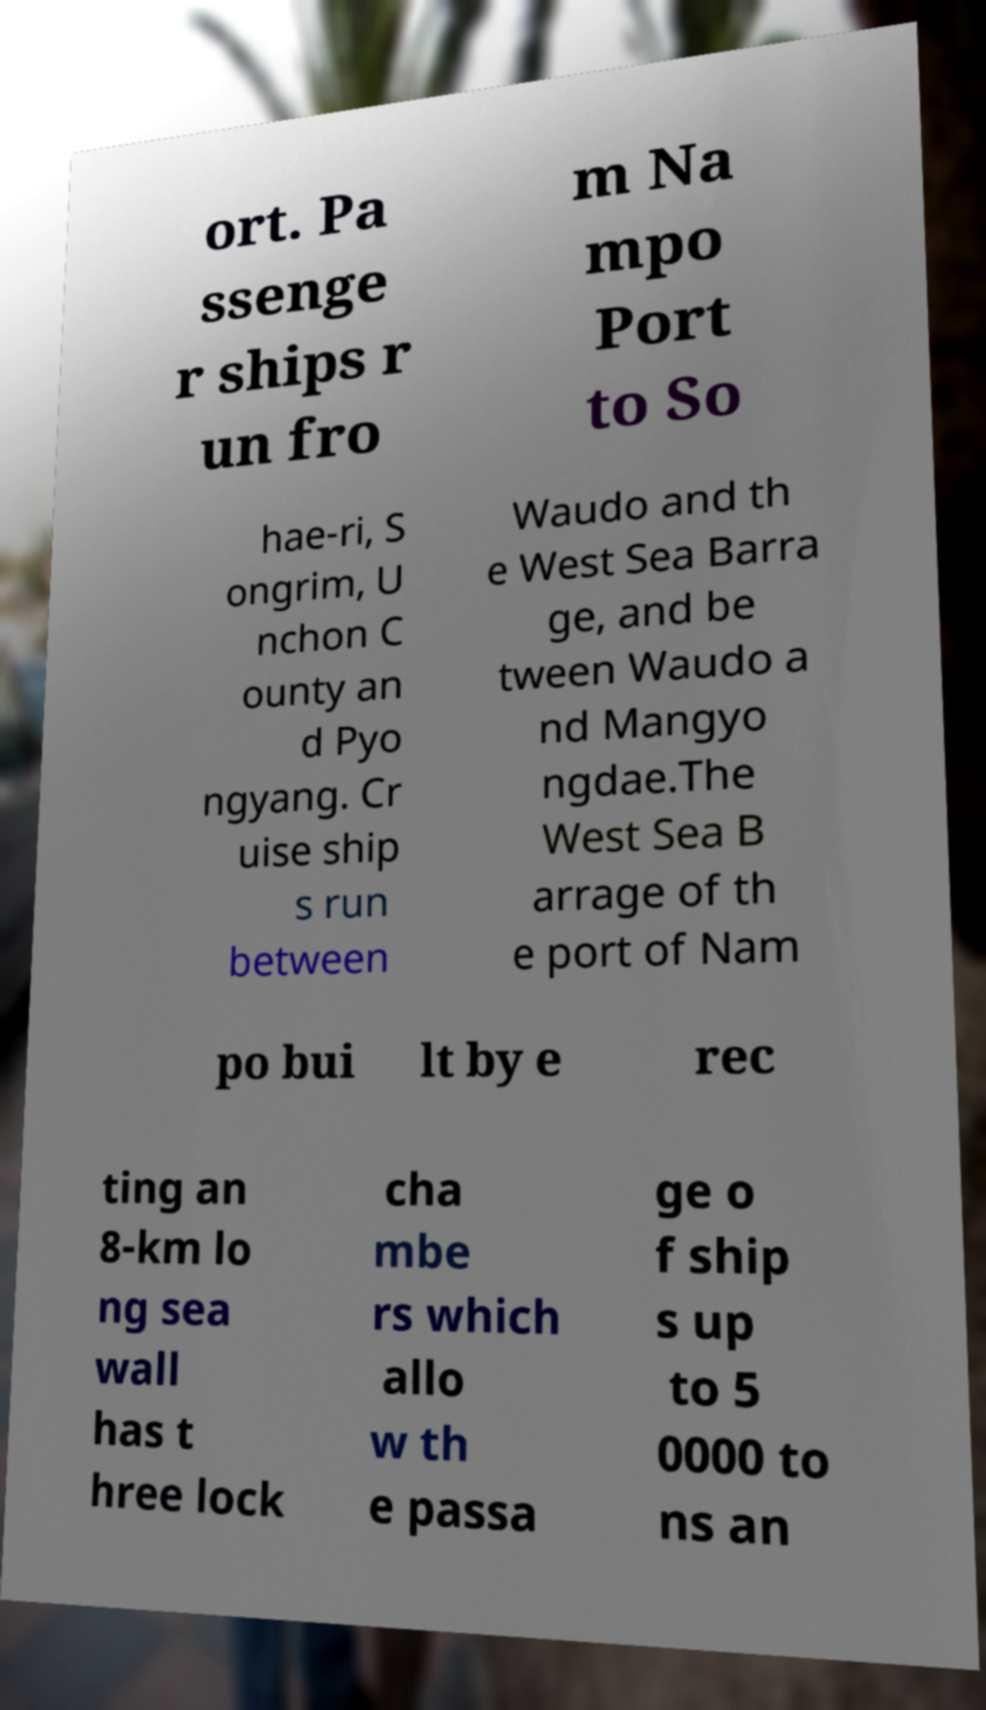Please identify and transcribe the text found in this image. ort. Pa ssenge r ships r un fro m Na mpo Port to So hae-ri, S ongrim, U nchon C ounty an d Pyo ngyang. Cr uise ship s run between Waudo and th e West Sea Barra ge, and be tween Waudo a nd Mangyo ngdae.The West Sea B arrage of th e port of Nam po bui lt by e rec ting an 8-km lo ng sea wall has t hree lock cha mbe rs which allo w th e passa ge o f ship s up to 5 0000 to ns an 